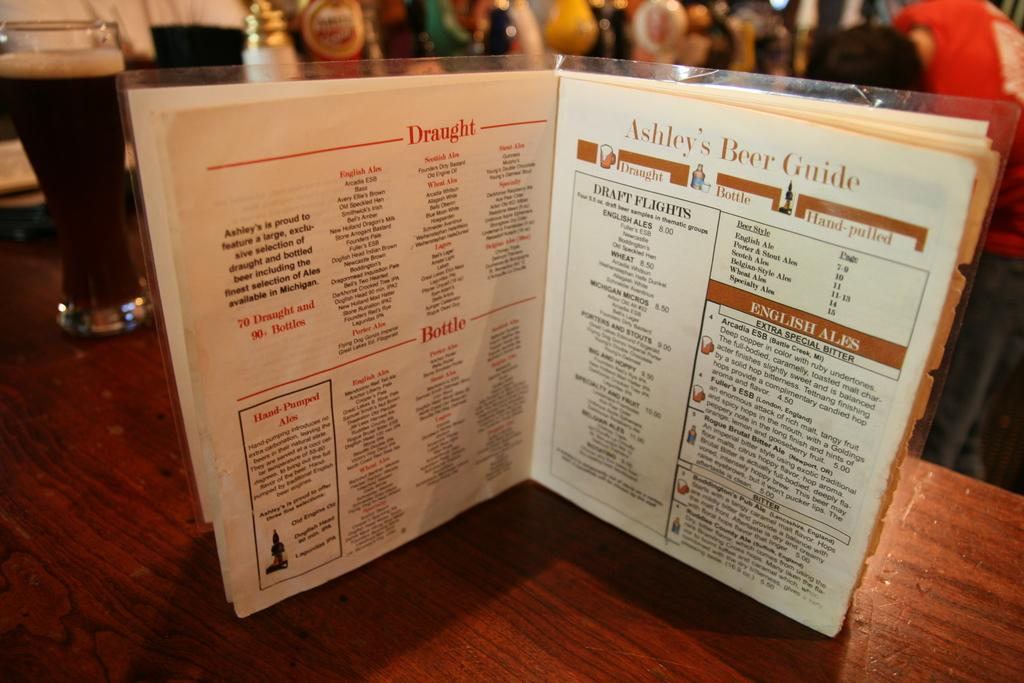Provide a one-sentence caption for the provided image. Abby's Beer Guide sits open on a table next to pints of ale. 